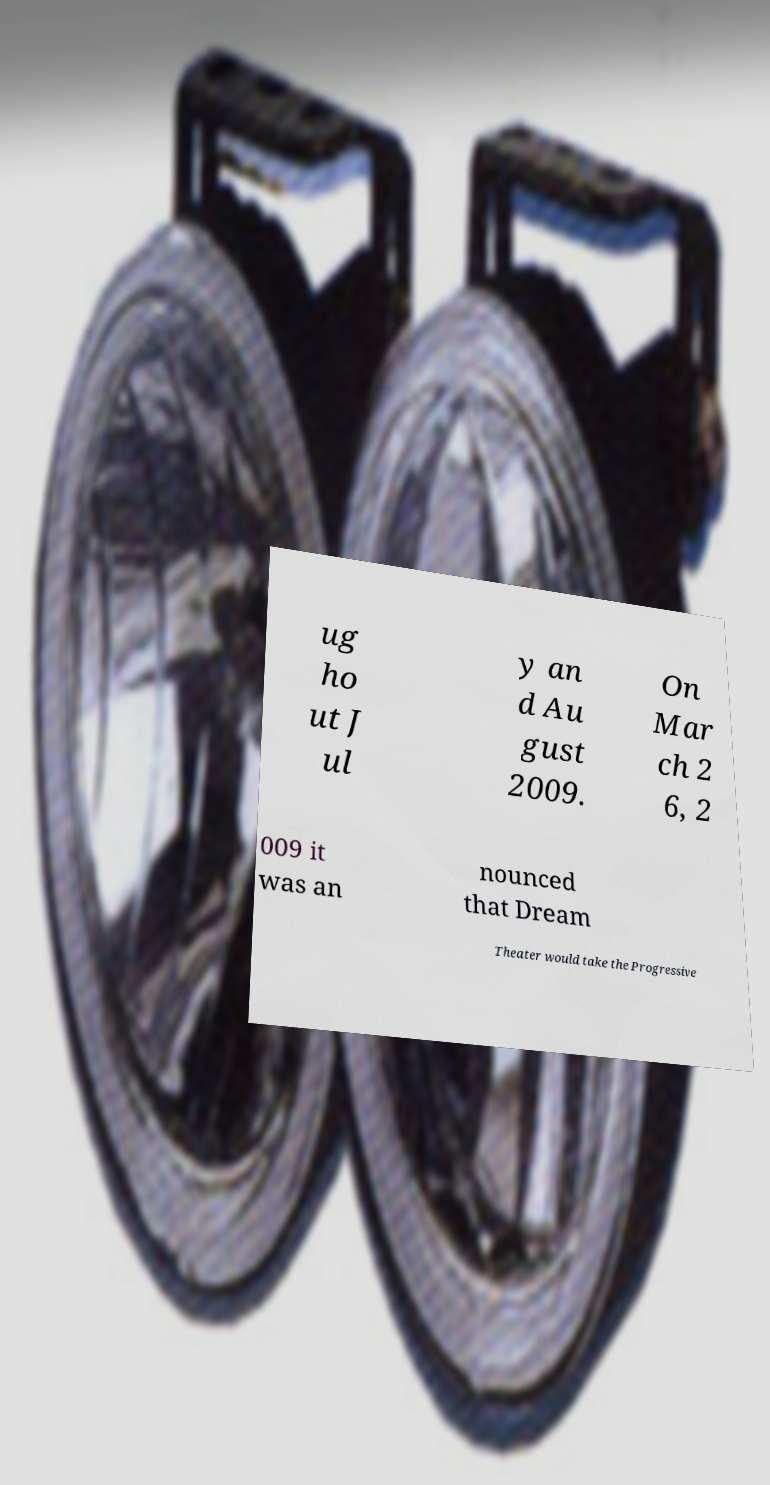Could you extract and type out the text from this image? ug ho ut J ul y an d Au gust 2009. On Mar ch 2 6, 2 009 it was an nounced that Dream Theater would take the Progressive 